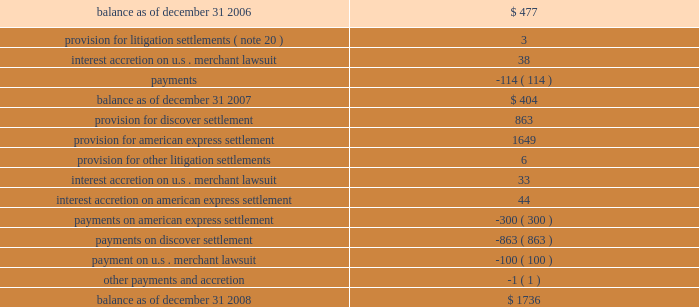We recorded liabilities for certain litigation settlements in prior periods .
Total liabilities for litigation settlements changed from december 31 , 2006 , as follows : ( in millions ) .
* note that table may not sum due to rounding .
Contribution expense 2014foundation in may 2006 , in conjunction with our initial public offering ( 201cipo 201d ) , we issued 13496933 shares of our class a common stock as a donation to the foundation that is incorporated in canada and controlled by directors who are independent of us and our customers .
The foundation builds on mastercard 2019s existing charitable giving commitments by continuing to support programs and initiatives that help children and youth to access education , understand and utilize technology , and develop the skills necessary to succeed in a diverse and global work force .
The vision of the foundation is to make the economy work for everybody by advancing innovative programs in areas of microfinance and youth education .
In connection with the donation of the class a common stock , we recorded an expense of $ 395 million which was equal to the aggregate value of the shares we donated .
In both 2007 and 2006 , we recorded expenses of $ 20 million for cash donations we made to the foundation , completing our intention , announced at the time of the ipo , to donate approximately $ 40 million in cash to the foundation in support of its operating expenses and charitable disbursements for the first four years of its operations .
We may make additional cash contributions to the foundation in the future .
The cash and stock donations to the foundation are generally not deductible by mastercard for tax purposes .
As a result of this difference between the financial statement and tax treatments of the donations , our effective income tax rate for the year ended december 31 , 2006 is significantly higher than our effective income tax rates for 2007 and 2008 .
Depreciation and amortization depreciation and amortization expenses increased $ 14 million in 2008 and decreased $ 2 million in 2007 .
The increase in depreciation and amortization expense in 2008 is primarily due to increased investments in leasehold and building improvements , data center equipment and capitalized software .
The decrease in depreciation and amortization expense in 2007 was primarily related to certain assets becoming fully depreciated .
Depreciation and amortization will increase as we continue to invest in leasehold and building improvements , data center equipment and capitalized software. .
What is the net change in the balance of total liabilities for litigation settlements during 2008? 
Computations: (1736 - 404)
Answer: 1332.0. 